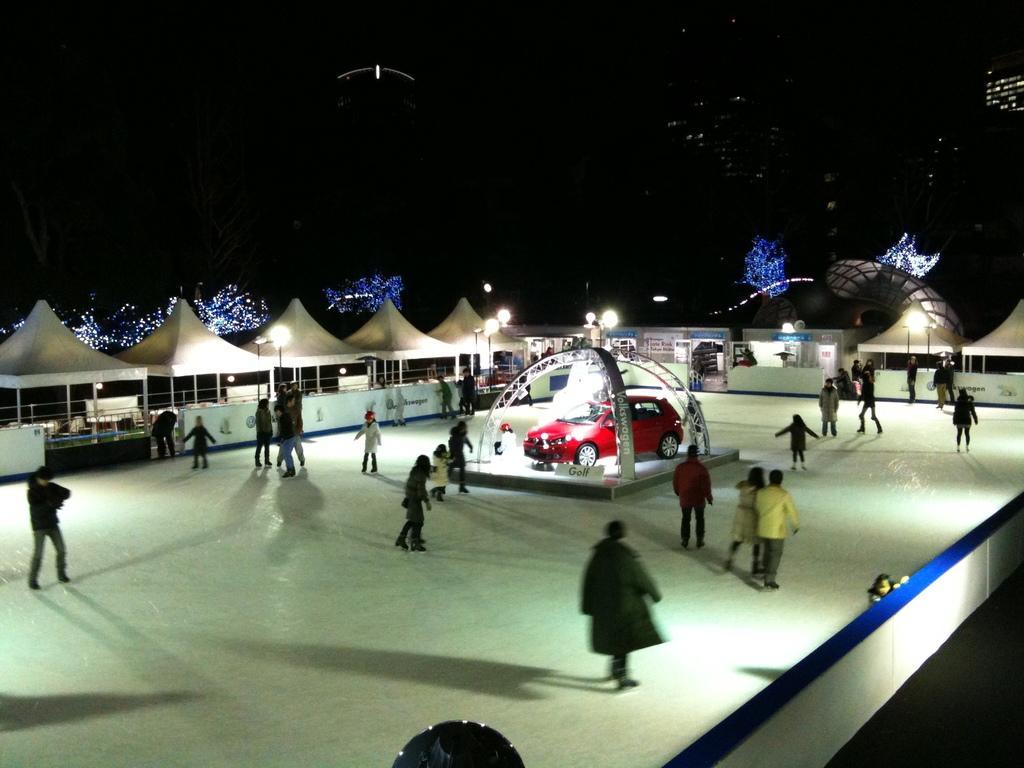In one or two sentences, can you explain what this image depicts? In this picture, we see many people ice skating. In the middle of the picture, we see a red color car and behind that, we see an iron fence and we even see umbrella tents which are in white color. At the top of the picture, it is black in color. This picture might be clicked in the dark. 